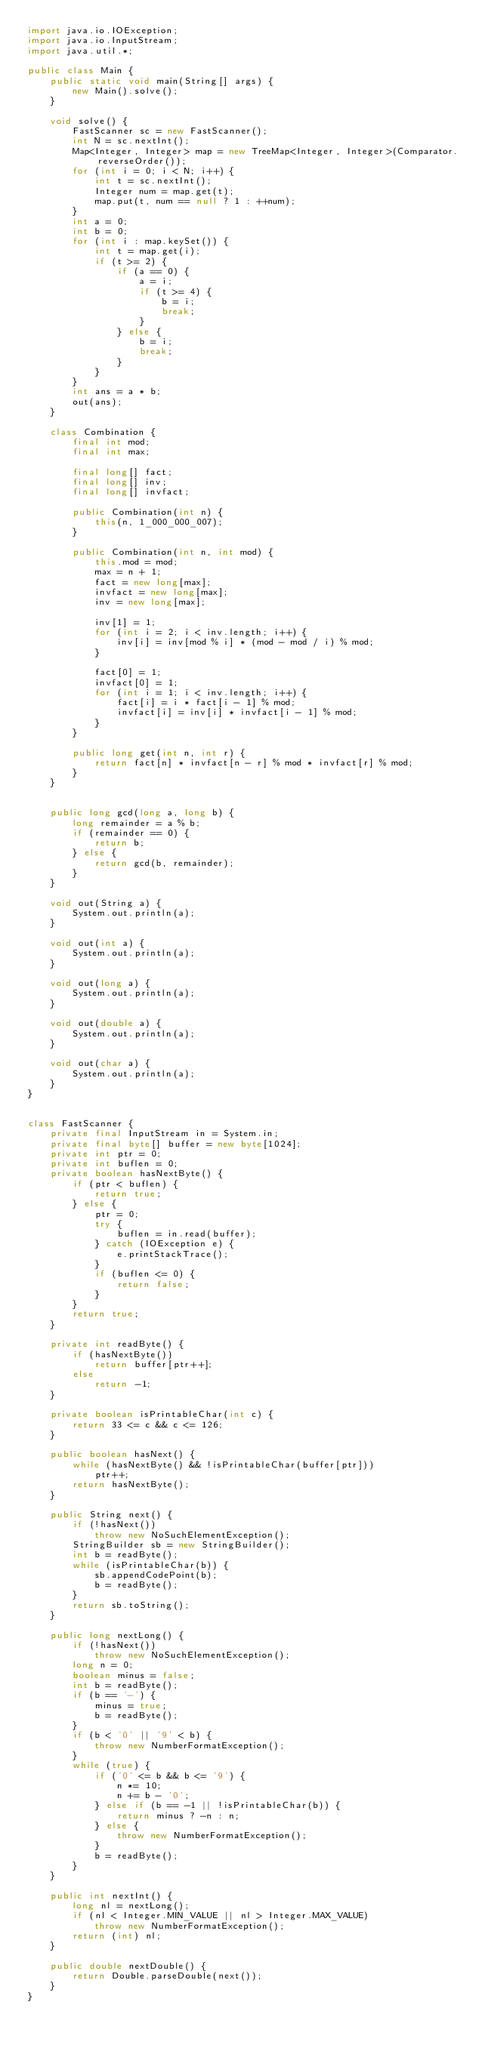Convert code to text. <code><loc_0><loc_0><loc_500><loc_500><_Java_>import java.io.IOException;
import java.io.InputStream;
import java.util.*;

public class Main {
	public static void main(String[] args) {
		new Main().solve();
	}

	void solve() {
		FastScanner sc = new FastScanner();
		int N = sc.nextInt();
		Map<Integer, Integer> map = new TreeMap<Integer, Integer>(Comparator.reverseOrder());
		for (int i = 0; i < N; i++) {
			int t = sc.nextInt();
			Integer num = map.get(t);
			map.put(t, num == null ? 1 : ++num);
		}
		int a = 0;
		int b = 0;
		for (int i : map.keySet()) {
			int t = map.get(i);
			if (t >= 2) {
				if (a == 0) {
					a = i;
					if (t >= 4) {
						b = i;
						break;
					}
				} else {
					b = i;
					break;
				}
			}
		}
		int ans = a * b;
		out(ans);
	}

	class Combination {
		final int mod;
		final int max;

		final long[] fact;
		final long[] inv;
		final long[] invfact;

		public Combination(int n) {
			this(n, 1_000_000_007);
		}

		public Combination(int n, int mod) {
			this.mod = mod;
			max = n + 1;
			fact = new long[max];
			invfact = new long[max];
			inv = new long[max];

			inv[1] = 1;
			for (int i = 2; i < inv.length; i++) {
				inv[i] = inv[mod % i] * (mod - mod / i) % mod;
			}

			fact[0] = 1;
			invfact[0] = 1;
			for (int i = 1; i < inv.length; i++) {
				fact[i] = i * fact[i - 1] % mod;
				invfact[i] = inv[i] * invfact[i - 1] % mod;
			}
		}

		public long get(int n, int r) {
			return fact[n] * invfact[n - r] % mod * invfact[r] % mod;
		}
	}


	public long gcd(long a, long b) {
		long remainder = a % b;
		if (remainder == 0) {
			return b;
		} else {
			return gcd(b, remainder);
		}
	}

	void out(String a) {
		System.out.println(a);
	}

	void out(int a) {
		System.out.println(a);
	}

	void out(long a) {
		System.out.println(a);
	}

	void out(double a) {
		System.out.println(a);
	}

	void out(char a) {
		System.out.println(a);
	}
}


class FastScanner {
    private final InputStream in = System.in;
    private final byte[] buffer = new byte[1024];
    private int ptr = 0;
    private int buflen = 0;
    private boolean hasNextByte() {
        if (ptr < buflen) {
            return true;
        } else {
            ptr = 0;
            try {
                buflen = in.read(buffer);
            } catch (IOException e) {
                e.printStackTrace();
            }
            if (buflen <= 0) {
                return false;
            }
        }
        return true;
    }

    private int readByte() {
        if (hasNextByte())
            return buffer[ptr++];
        else
            return -1;
    }

    private boolean isPrintableChar(int c) {
        return 33 <= c && c <= 126;
    }

    public boolean hasNext() {
        while (hasNextByte() && !isPrintableChar(buffer[ptr]))
            ptr++;
        return hasNextByte();
    }

    public String next() {
        if (!hasNext())
            throw new NoSuchElementException();
        StringBuilder sb = new StringBuilder();
        int b = readByte();
        while (isPrintableChar(b)) {
            sb.appendCodePoint(b);
            b = readByte();
        }
        return sb.toString();
    }

    public long nextLong() {
        if (!hasNext())
            throw new NoSuchElementException();
        long n = 0;
        boolean minus = false;
        int b = readByte();
        if (b == '-') {
            minus = true;
            b = readByte();
        }
        if (b < '0' || '9' < b) {
            throw new NumberFormatException();
        }
        while (true) {
            if ('0' <= b && b <= '9') {
                n *= 10;
                n += b - '0';
            } else if (b == -1 || !isPrintableChar(b)) {
                return minus ? -n : n;
            } else {
                throw new NumberFormatException();
            }
            b = readByte();
        }
    }

    public int nextInt() {
        long nl = nextLong();
        if (nl < Integer.MIN_VALUE || nl > Integer.MAX_VALUE)
            throw new NumberFormatException();
        return (int) nl;
    }

    public double nextDouble() {
        return Double.parseDouble(next());
    }
}
</code> 